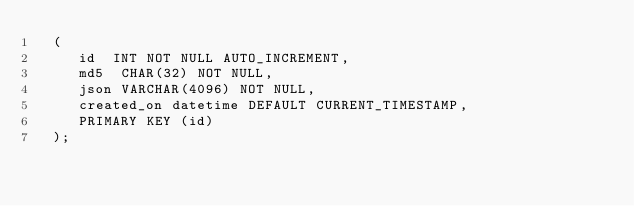<code> <loc_0><loc_0><loc_500><loc_500><_SQL_>  (
     id  INT NOT NULL AUTO_INCREMENT,
     md5  CHAR(32) NOT NULL,
     json VARCHAR(4096) NOT NULL,
     created_on datetime DEFAULT CURRENT_TIMESTAMP,
     PRIMARY KEY (id)
  );
</code> 